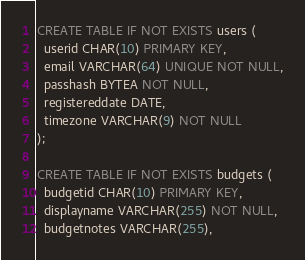Convert code to text. <code><loc_0><loc_0><loc_500><loc_500><_SQL_>CREATE TABLE IF NOT EXISTS users (
  userid CHAR(10) PRIMARY KEY,
  email VARCHAR(64) UNIQUE NOT NULL,
  passhash BYTEA NOT NULL,
  registereddate DATE,
  timezone VARCHAR(9) NOT NULL
);

CREATE TABLE IF NOT EXISTS budgets (
  budgetid CHAR(10) PRIMARY KEY,
  displayname VARCHAR(255) NOT NULL,
  budgetnotes VARCHAR(255),</code> 